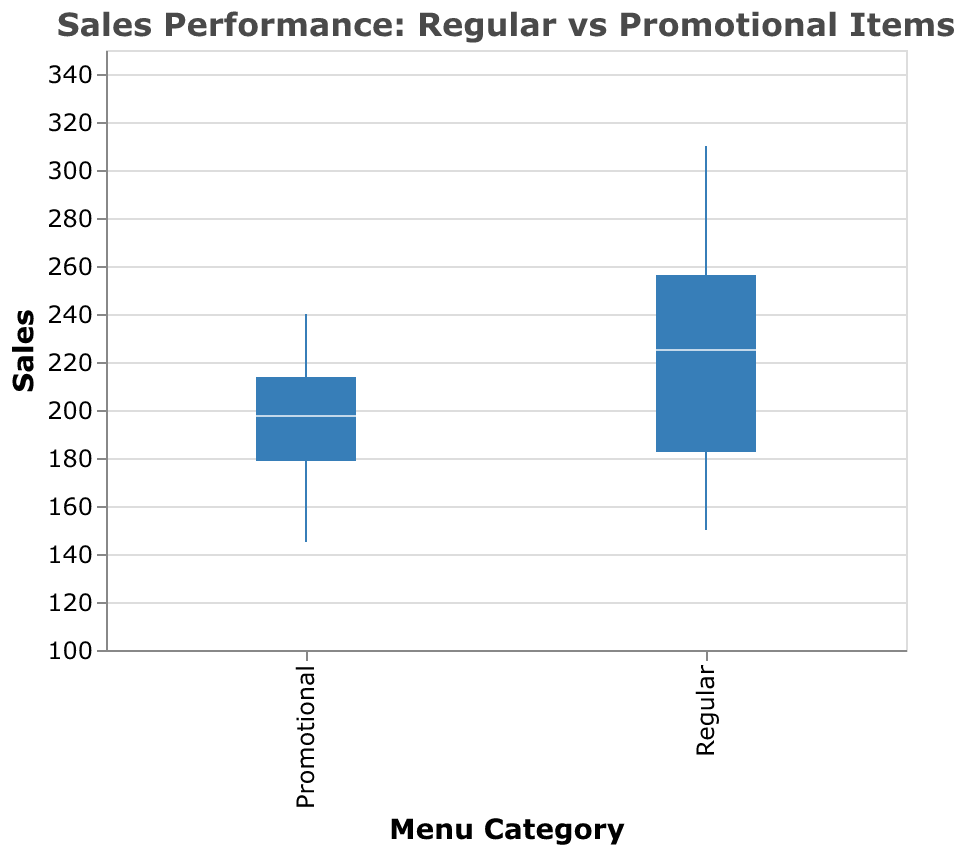What is the median sales value for regular menu items? The median value for regular items is the middle value when they are ordered from lowest to highest. In the figure, this is indicated by the horizontal line inside the box of the box plot for the "Regular" category.
Answer: 230 What item falls into the category with lower overall sales? By comparing the whiskers (the lines extending from the boxes) and the position of the boxes, we see that the "Promotional" items category generally has lower sales values.
Answer: Promotional Which category shows a wider range of sales values? The range is indicated by the length of the box and the whiskers. The "Regular" category shows a wider range from the minimum to maximum sales values compared to the "Promotional" category.
Answer: Regular What is the highest sales value observed in the promotional items category? The highest sales value is represented by the upper whisker endpoint in the "Promotional" category's box plot. This value is identified as 240.
Answer: 240 How do the median sales values of the two categories compare? The median sales value is represented by the horizontal line within the box. For regular items, it is 230, whereas for promotional items, it is lower.
Answer: Regular items have a higher median Which category has more outliers? Outliers are shown as individual points outside the whiskers. The figure indicates that the "Regular" category has no outliers, while the "Promotional" category also has no visible outliers.
Answer: Neither What is the sales value at the 25th percentile for regular menu items? The 25th percentile is the lower boundary of the box in the box plot. This approximate value can be read directly from the lower side of the "Regular" category box plot.
Answer: 190 Is the interquartile range (IQR) larger for regular or promotional items? The IQR is the difference between the 75th percentile and the 25th percentile. The box size in the "Regular" category is larger compared to the "Promotional" category's box, indicating a larger IQR.
Answer: Regular Which category has the highest concentration of sales values? The concentration of sales values is indicated by the size of the box. Since the box for the "Promotional" category is smaller, it indicates a higher concentration of sales values within the middle 50% range.
Answer: Promotional What is the lowest sales value observed in the regular menu items category? The lowest sales value is shown by the lower whisker endpoint in the "Regular" category's box plot, which is 150.
Answer: 150 